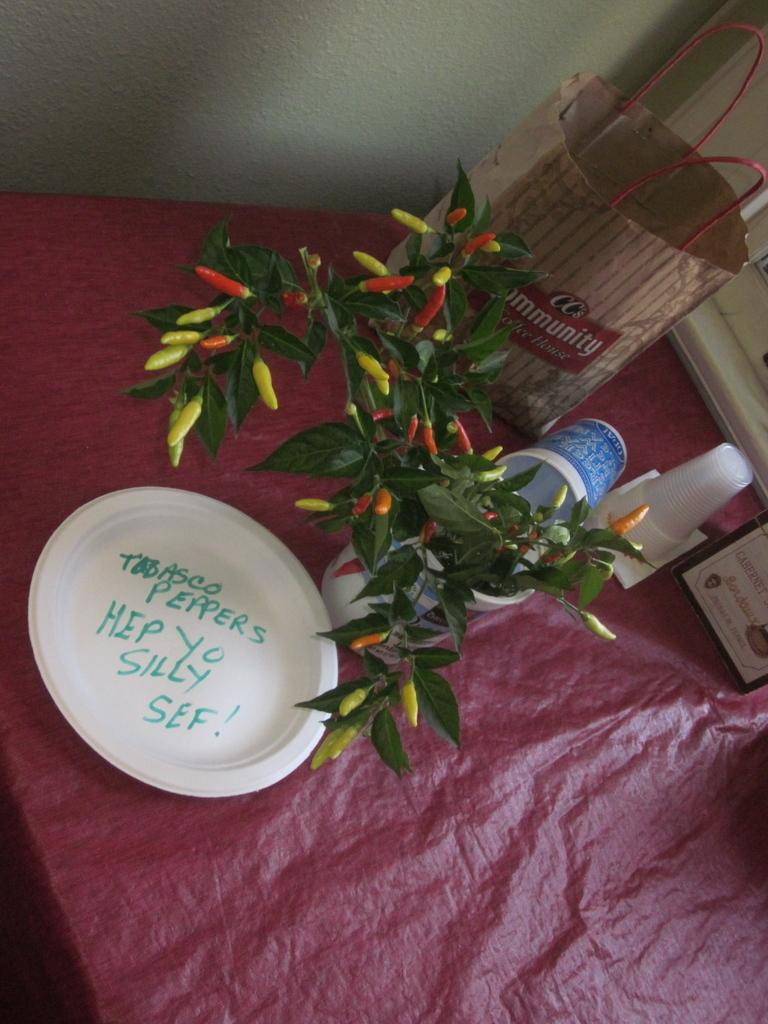Where was the image taken? The image was taken indoors. What can be seen in the background of the image? There is a wall in the background of the image. What furniture is present in the image? There is a table with a tablecloth in the image. What items are on the table? A flower vase, a plate, a bag, and cups are on the table. What type of heart can be seen beating in the image? There is no heart visible in the image. What rail is present in the image? There is no rail present in the image. 